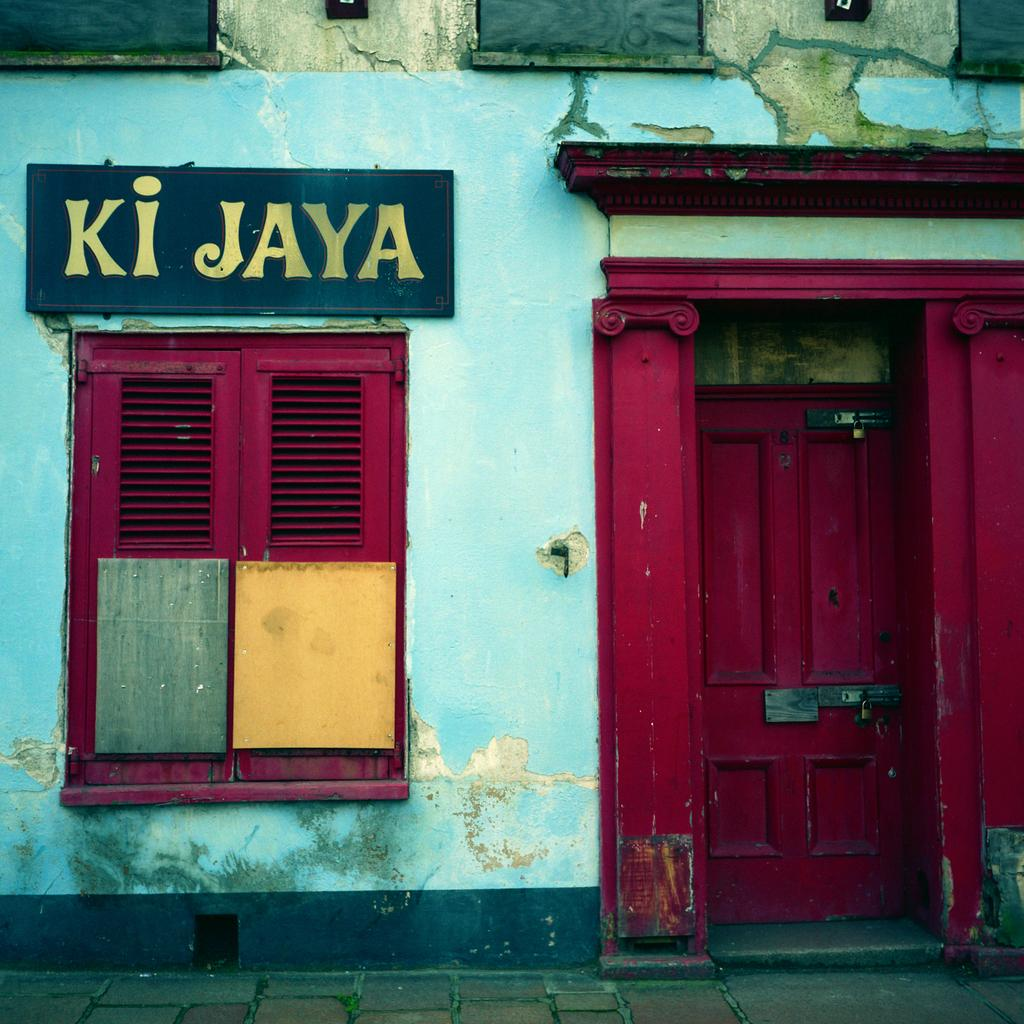What type of structure can be seen in the image? There is a wall in the image. What is attached to the wall? There is a board and a window in the image. Is there an entrance visible in the image? Yes, there is a door in the image. How is the door secured? There are locks in the image. What else can be seen in the image besides the wall, board, window, and door? There are objects in the image. What is the ground surface like in the image? There is a pathway at the bottom portion of the image. What type of wind can be seen blowing through the neck of the wool in the image? There is no wind, neck, or wool present in the image. 